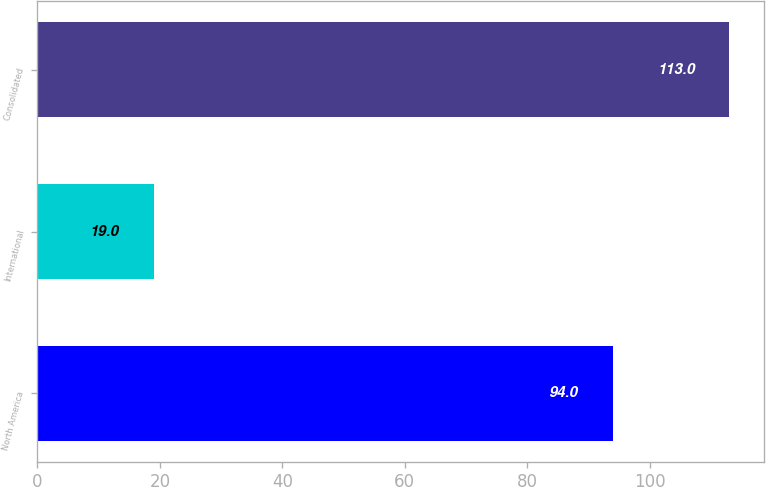<chart> <loc_0><loc_0><loc_500><loc_500><bar_chart><fcel>North America<fcel>International<fcel>Consolidated<nl><fcel>94<fcel>19<fcel>113<nl></chart> 